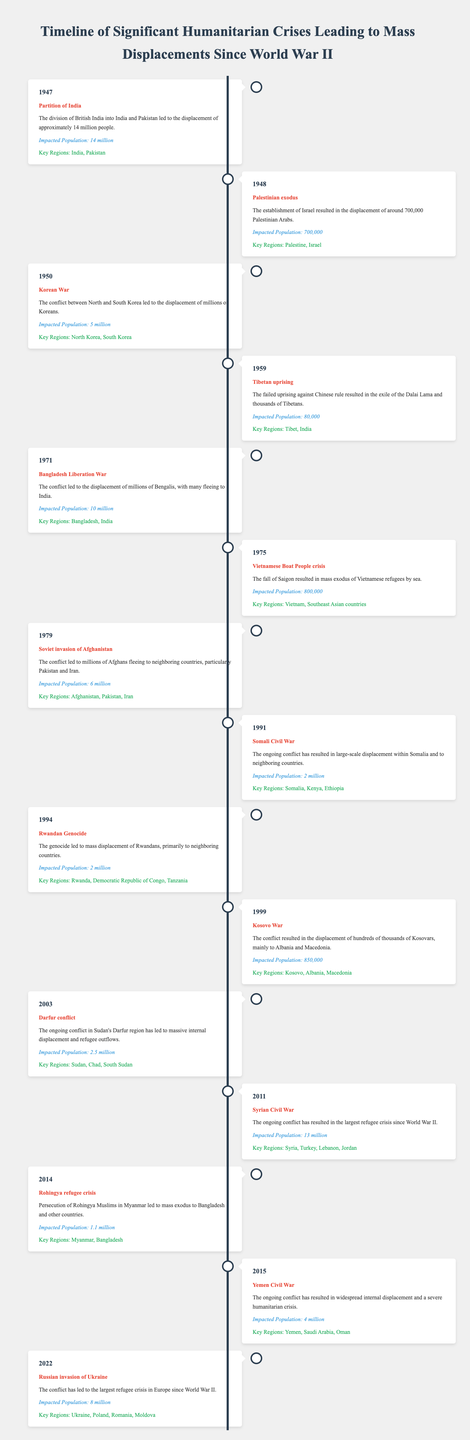What humanitarian crisis in 1971 resulted in 10 million displacements? The table indicates that the event in 1971 was the Bangladesh Liberation War, which led to the displacement of 10 million people.
Answer: Bangladesh Liberation War Which event had the largest impact on population displacement, according to the table? The data shows that the Syrian Civil War in 2011 resulted in the displacement of 13 million people, which is the largest figure among all listed events.
Answer: Syrian Civil War (13 million) Is it true that the Rwandan Genocide resulted in a greater displacement than the Kosovo War? By comparing the impacted populations, the Rwandan Genocide resulted in 2 million displacements while the Kosovo War resulted in 850,000, so the statement is false.
Answer: No What is the total displaced population from the conflicts in the years 2014 and 2015? The Rohingya refugee crisis in 2014 displaced 1.1 million people, and the Yemen Civil War in 2015 displaced 4 million people. Adding these, 1.1 million + 4 million = 5.1 million.
Answer: 5.1 million Which two events occurred in the 1990s, and how many people were displaced by each? The table shows the Somali Civil War in 1991 displaced 2 million and the Rwandan Genocide in 1994 also displaced 2 million. These two events occurred in the 1990s, and both had an equal impact on displacement.
Answer: Somali Civil War (2 million), Rwandan Genocide (2 million) How many humanitarian crises listed in the table resulted in displacements of over 5 million individuals? Analyzing the table, the conflicts the resulted in over 5 million displacements are: Partition of India (14 million), Korean War (5 million), Soviet invasion of Afghanistan (6 million), Syrian Civil War (13 million), and the Russian invasion of Ukraine (8 million). Thus, there are five such crises.
Answer: 5 What was the population displacement caused by the Vietnamese Boat People crisis in 1975? According to the table, the Vietnamese Boat People crisis in 1975 resulted in the displacement of 800,000 individuals.
Answer: 800,000 Did the Palestinian exodus in 1948 result in a higher displacement than the Tibetan uprising in 1959? The Palestinian exodus in 1948 led to 700,000 displacements, while the Tibetan uprising in 1959 resulted in 80,000 displacements. Therefore, the Palestinian exodus had a higher impact.
Answer: Yes What key regions were primarily affected by the Syrian Civil War? The table specifies that the key regions impacted by the Syrian Civil War are Syria, Turkey, Lebanon, and Jordan. This highlights the widespread nature of the crisis across neighboring countries.
Answer: Syria, Turkey, Lebanon, Jordan 